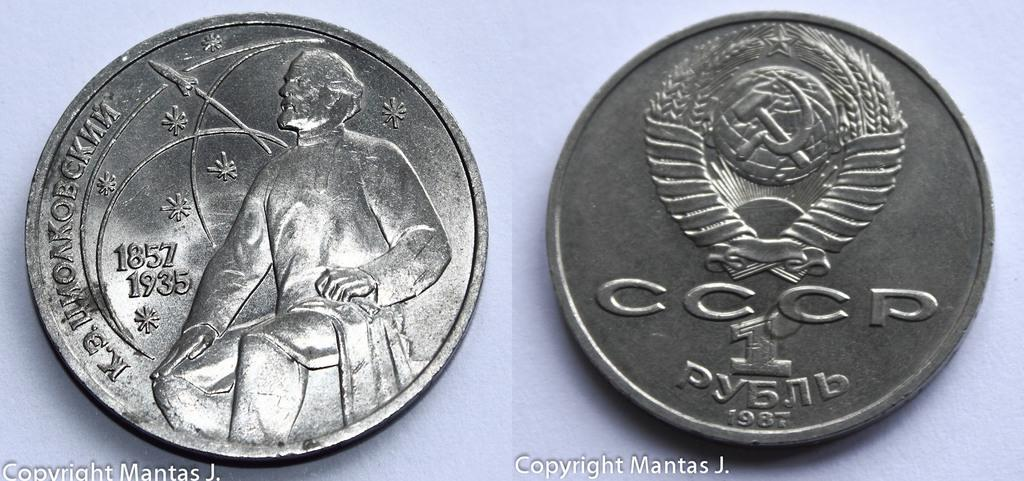<image>
Give a short and clear explanation of the subsequent image. A set of silver coins with the numbers 1857 and 1935 on it. 